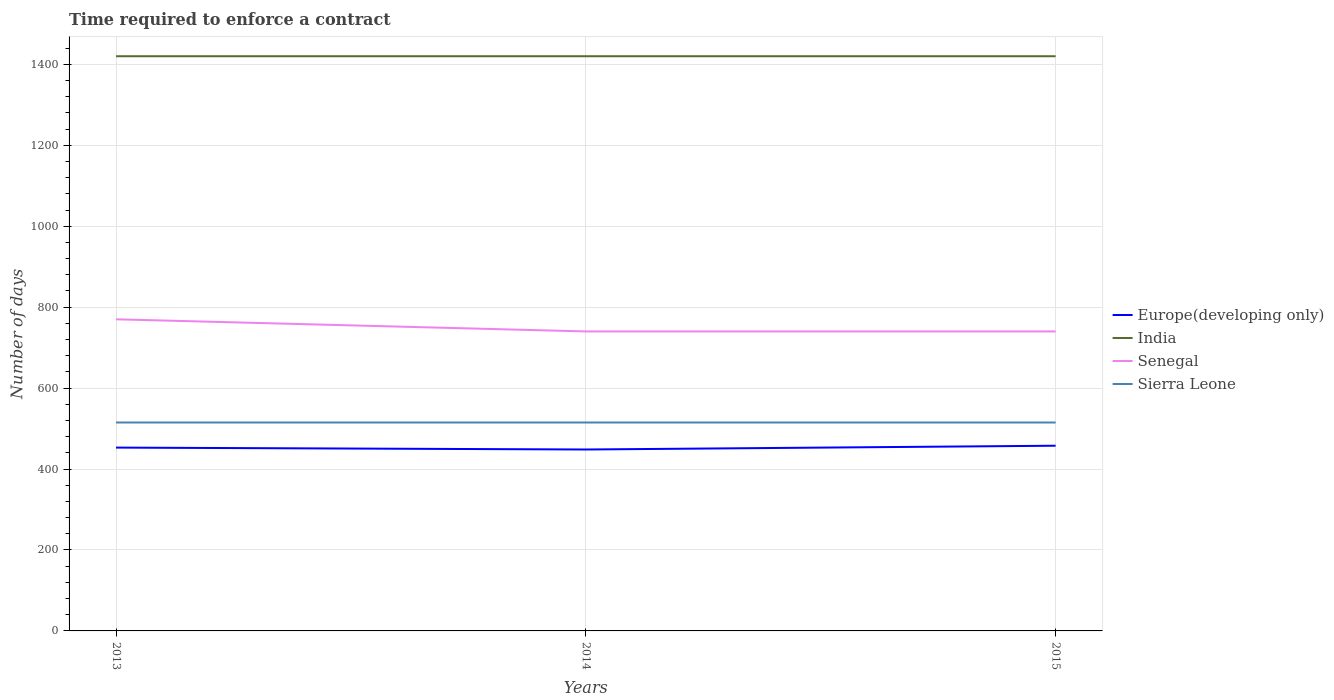How many different coloured lines are there?
Keep it short and to the point. 4. Across all years, what is the maximum number of days required to enforce a contract in Europe(developing only)?
Your response must be concise. 448.26. What is the total number of days required to enforce a contract in India in the graph?
Your answer should be compact. 0. What is the difference between the highest and the second highest number of days required to enforce a contract in Senegal?
Your response must be concise. 30. What is the difference between the highest and the lowest number of days required to enforce a contract in Sierra Leone?
Keep it short and to the point. 0. Is the number of days required to enforce a contract in Senegal strictly greater than the number of days required to enforce a contract in India over the years?
Make the answer very short. Yes. What is the difference between two consecutive major ticks on the Y-axis?
Offer a terse response. 200. Are the values on the major ticks of Y-axis written in scientific E-notation?
Your answer should be compact. No. Does the graph contain any zero values?
Keep it short and to the point. No. Where does the legend appear in the graph?
Your response must be concise. Center right. What is the title of the graph?
Ensure brevity in your answer.  Time required to enforce a contract. What is the label or title of the X-axis?
Keep it short and to the point. Years. What is the label or title of the Y-axis?
Give a very brief answer. Number of days. What is the Number of days in Europe(developing only) in 2013?
Give a very brief answer. 453. What is the Number of days in India in 2013?
Ensure brevity in your answer.  1420. What is the Number of days of Senegal in 2013?
Offer a very short reply. 770. What is the Number of days in Sierra Leone in 2013?
Ensure brevity in your answer.  515. What is the Number of days of Europe(developing only) in 2014?
Make the answer very short. 448.26. What is the Number of days of India in 2014?
Your answer should be compact. 1420. What is the Number of days of Senegal in 2014?
Your answer should be compact. 740. What is the Number of days of Sierra Leone in 2014?
Your response must be concise. 515. What is the Number of days of Europe(developing only) in 2015?
Offer a very short reply. 457.63. What is the Number of days in India in 2015?
Make the answer very short. 1420. What is the Number of days of Senegal in 2015?
Keep it short and to the point. 740. What is the Number of days of Sierra Leone in 2015?
Keep it short and to the point. 515. Across all years, what is the maximum Number of days of Europe(developing only)?
Make the answer very short. 457.63. Across all years, what is the maximum Number of days of India?
Give a very brief answer. 1420. Across all years, what is the maximum Number of days of Senegal?
Your answer should be very brief. 770. Across all years, what is the maximum Number of days in Sierra Leone?
Offer a very short reply. 515. Across all years, what is the minimum Number of days of Europe(developing only)?
Keep it short and to the point. 448.26. Across all years, what is the minimum Number of days of India?
Give a very brief answer. 1420. Across all years, what is the minimum Number of days of Senegal?
Offer a very short reply. 740. Across all years, what is the minimum Number of days of Sierra Leone?
Keep it short and to the point. 515. What is the total Number of days in Europe(developing only) in the graph?
Make the answer very short. 1358.89. What is the total Number of days of India in the graph?
Keep it short and to the point. 4260. What is the total Number of days in Senegal in the graph?
Your answer should be compact. 2250. What is the total Number of days in Sierra Leone in the graph?
Keep it short and to the point. 1545. What is the difference between the Number of days in Europe(developing only) in 2013 and that in 2014?
Your answer should be very brief. 4.74. What is the difference between the Number of days in India in 2013 and that in 2014?
Keep it short and to the point. 0. What is the difference between the Number of days of Sierra Leone in 2013 and that in 2014?
Offer a very short reply. 0. What is the difference between the Number of days of Europe(developing only) in 2013 and that in 2015?
Make the answer very short. -4.63. What is the difference between the Number of days in India in 2013 and that in 2015?
Offer a terse response. 0. What is the difference between the Number of days of Europe(developing only) in 2014 and that in 2015?
Keep it short and to the point. -9.37. What is the difference between the Number of days of Senegal in 2014 and that in 2015?
Keep it short and to the point. 0. What is the difference between the Number of days in Sierra Leone in 2014 and that in 2015?
Offer a very short reply. 0. What is the difference between the Number of days of Europe(developing only) in 2013 and the Number of days of India in 2014?
Provide a short and direct response. -967. What is the difference between the Number of days in Europe(developing only) in 2013 and the Number of days in Senegal in 2014?
Give a very brief answer. -287. What is the difference between the Number of days in Europe(developing only) in 2013 and the Number of days in Sierra Leone in 2014?
Ensure brevity in your answer.  -62. What is the difference between the Number of days of India in 2013 and the Number of days of Senegal in 2014?
Your response must be concise. 680. What is the difference between the Number of days in India in 2013 and the Number of days in Sierra Leone in 2014?
Provide a short and direct response. 905. What is the difference between the Number of days of Senegal in 2013 and the Number of days of Sierra Leone in 2014?
Make the answer very short. 255. What is the difference between the Number of days of Europe(developing only) in 2013 and the Number of days of India in 2015?
Provide a short and direct response. -967. What is the difference between the Number of days in Europe(developing only) in 2013 and the Number of days in Senegal in 2015?
Provide a succinct answer. -287. What is the difference between the Number of days in Europe(developing only) in 2013 and the Number of days in Sierra Leone in 2015?
Your answer should be compact. -62. What is the difference between the Number of days in India in 2013 and the Number of days in Senegal in 2015?
Give a very brief answer. 680. What is the difference between the Number of days of India in 2013 and the Number of days of Sierra Leone in 2015?
Provide a succinct answer. 905. What is the difference between the Number of days of Senegal in 2013 and the Number of days of Sierra Leone in 2015?
Your response must be concise. 255. What is the difference between the Number of days in Europe(developing only) in 2014 and the Number of days in India in 2015?
Your response must be concise. -971.74. What is the difference between the Number of days in Europe(developing only) in 2014 and the Number of days in Senegal in 2015?
Provide a short and direct response. -291.74. What is the difference between the Number of days of Europe(developing only) in 2014 and the Number of days of Sierra Leone in 2015?
Your response must be concise. -66.74. What is the difference between the Number of days of India in 2014 and the Number of days of Senegal in 2015?
Give a very brief answer. 680. What is the difference between the Number of days of India in 2014 and the Number of days of Sierra Leone in 2015?
Your answer should be compact. 905. What is the difference between the Number of days in Senegal in 2014 and the Number of days in Sierra Leone in 2015?
Ensure brevity in your answer.  225. What is the average Number of days of Europe(developing only) per year?
Give a very brief answer. 452.96. What is the average Number of days of India per year?
Your answer should be compact. 1420. What is the average Number of days in Senegal per year?
Offer a very short reply. 750. What is the average Number of days of Sierra Leone per year?
Offer a terse response. 515. In the year 2013, what is the difference between the Number of days in Europe(developing only) and Number of days in India?
Give a very brief answer. -967. In the year 2013, what is the difference between the Number of days in Europe(developing only) and Number of days in Senegal?
Make the answer very short. -317. In the year 2013, what is the difference between the Number of days in Europe(developing only) and Number of days in Sierra Leone?
Provide a short and direct response. -62. In the year 2013, what is the difference between the Number of days of India and Number of days of Senegal?
Provide a succinct answer. 650. In the year 2013, what is the difference between the Number of days of India and Number of days of Sierra Leone?
Ensure brevity in your answer.  905. In the year 2013, what is the difference between the Number of days of Senegal and Number of days of Sierra Leone?
Keep it short and to the point. 255. In the year 2014, what is the difference between the Number of days in Europe(developing only) and Number of days in India?
Your response must be concise. -971.74. In the year 2014, what is the difference between the Number of days in Europe(developing only) and Number of days in Senegal?
Your answer should be very brief. -291.74. In the year 2014, what is the difference between the Number of days in Europe(developing only) and Number of days in Sierra Leone?
Offer a terse response. -66.74. In the year 2014, what is the difference between the Number of days of India and Number of days of Senegal?
Make the answer very short. 680. In the year 2014, what is the difference between the Number of days in India and Number of days in Sierra Leone?
Your answer should be very brief. 905. In the year 2014, what is the difference between the Number of days of Senegal and Number of days of Sierra Leone?
Keep it short and to the point. 225. In the year 2015, what is the difference between the Number of days of Europe(developing only) and Number of days of India?
Give a very brief answer. -962.37. In the year 2015, what is the difference between the Number of days in Europe(developing only) and Number of days in Senegal?
Provide a succinct answer. -282.37. In the year 2015, what is the difference between the Number of days of Europe(developing only) and Number of days of Sierra Leone?
Your response must be concise. -57.37. In the year 2015, what is the difference between the Number of days of India and Number of days of Senegal?
Provide a succinct answer. 680. In the year 2015, what is the difference between the Number of days in India and Number of days in Sierra Leone?
Provide a short and direct response. 905. In the year 2015, what is the difference between the Number of days in Senegal and Number of days in Sierra Leone?
Provide a short and direct response. 225. What is the ratio of the Number of days in Europe(developing only) in 2013 to that in 2014?
Your response must be concise. 1.01. What is the ratio of the Number of days of India in 2013 to that in 2014?
Provide a short and direct response. 1. What is the ratio of the Number of days in Senegal in 2013 to that in 2014?
Give a very brief answer. 1.04. What is the ratio of the Number of days in Europe(developing only) in 2013 to that in 2015?
Provide a short and direct response. 0.99. What is the ratio of the Number of days in India in 2013 to that in 2015?
Give a very brief answer. 1. What is the ratio of the Number of days of Senegal in 2013 to that in 2015?
Give a very brief answer. 1.04. What is the ratio of the Number of days of Sierra Leone in 2013 to that in 2015?
Your answer should be very brief. 1. What is the ratio of the Number of days of Europe(developing only) in 2014 to that in 2015?
Provide a short and direct response. 0.98. What is the ratio of the Number of days of Senegal in 2014 to that in 2015?
Give a very brief answer. 1. What is the difference between the highest and the second highest Number of days of Europe(developing only)?
Keep it short and to the point. 4.63. What is the difference between the highest and the second highest Number of days in India?
Your answer should be very brief. 0. What is the difference between the highest and the second highest Number of days in Senegal?
Keep it short and to the point. 30. What is the difference between the highest and the lowest Number of days in Europe(developing only)?
Keep it short and to the point. 9.37. What is the difference between the highest and the lowest Number of days in Sierra Leone?
Provide a succinct answer. 0. 